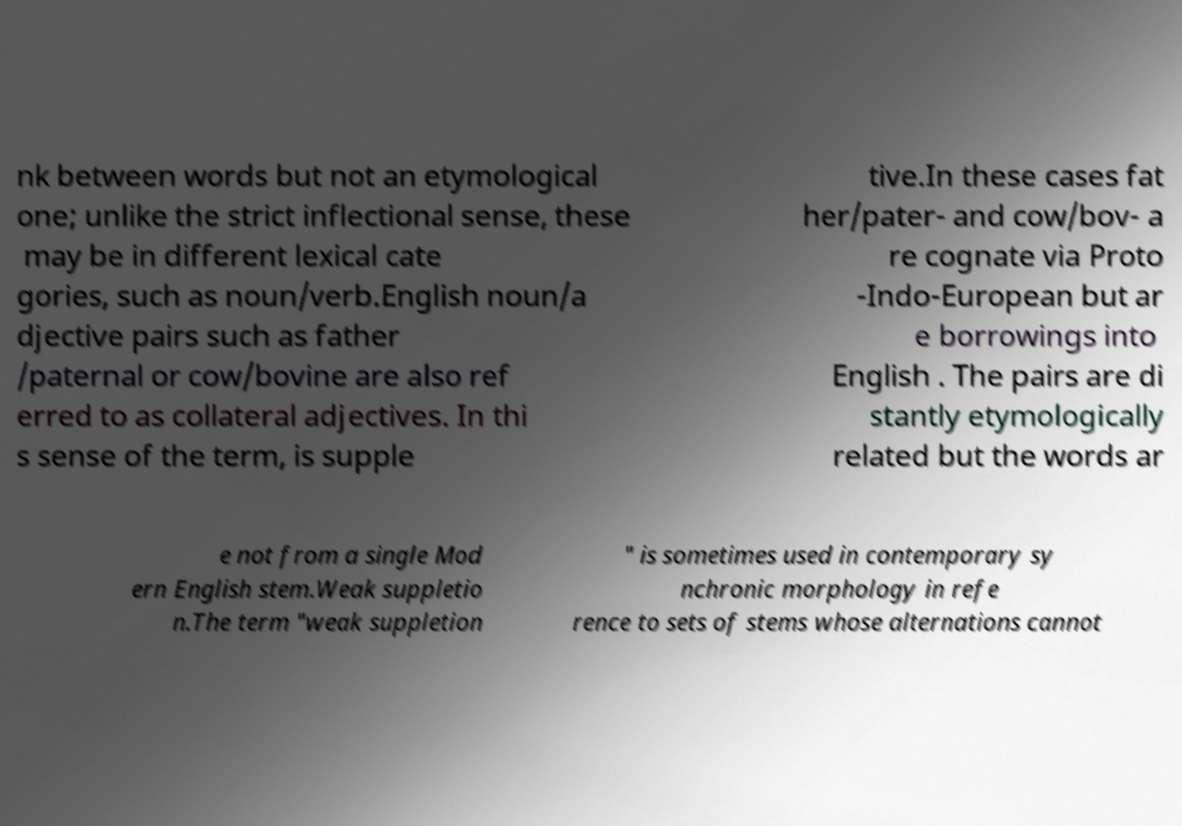For documentation purposes, I need the text within this image transcribed. Could you provide that? nk between words but not an etymological one; unlike the strict inflectional sense, these may be in different lexical cate gories, such as noun/verb.English noun/a djective pairs such as father /paternal or cow/bovine are also ref erred to as collateral adjectives. In thi s sense of the term, is supple tive.In these cases fat her/pater- and cow/bov- a re cognate via Proto -Indo-European but ar e borrowings into English . The pairs are di stantly etymologically related but the words ar e not from a single Mod ern English stem.Weak suppletio n.The term "weak suppletion " is sometimes used in contemporary sy nchronic morphology in refe rence to sets of stems whose alternations cannot 